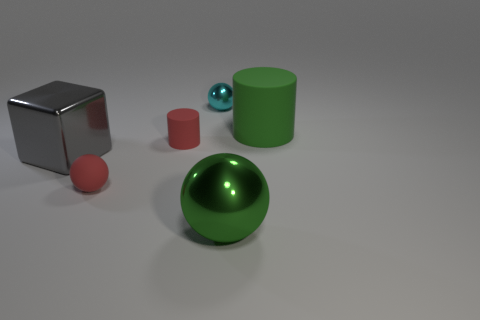There is a large cylinder that is the same material as the small red cylinder; what color is it?
Give a very brief answer. Green. Do the red rubber object that is in front of the red matte cylinder and the big green cylinder have the same size?
Make the answer very short. No. Is the material of the gray thing the same as the tiny object in front of the block?
Give a very brief answer. No. There is a tiny ball on the left side of the tiny cylinder; what color is it?
Ensure brevity in your answer.  Red. There is a small sphere in front of the large green matte cylinder; are there any green metal objects that are to the right of it?
Your answer should be very brief. Yes. There is a matte cylinder to the left of the tiny cyan metallic thing; is its color the same as the tiny sphere that is in front of the small cyan thing?
Give a very brief answer. Yes. What number of green matte things are left of the green matte cylinder?
Keep it short and to the point. 0. How many small rubber objects are the same color as the matte ball?
Your answer should be compact. 1. Are the big thing that is left of the large green metal thing and the small red sphere made of the same material?
Provide a succinct answer. No. How many blocks have the same material as the big green sphere?
Give a very brief answer. 1. 